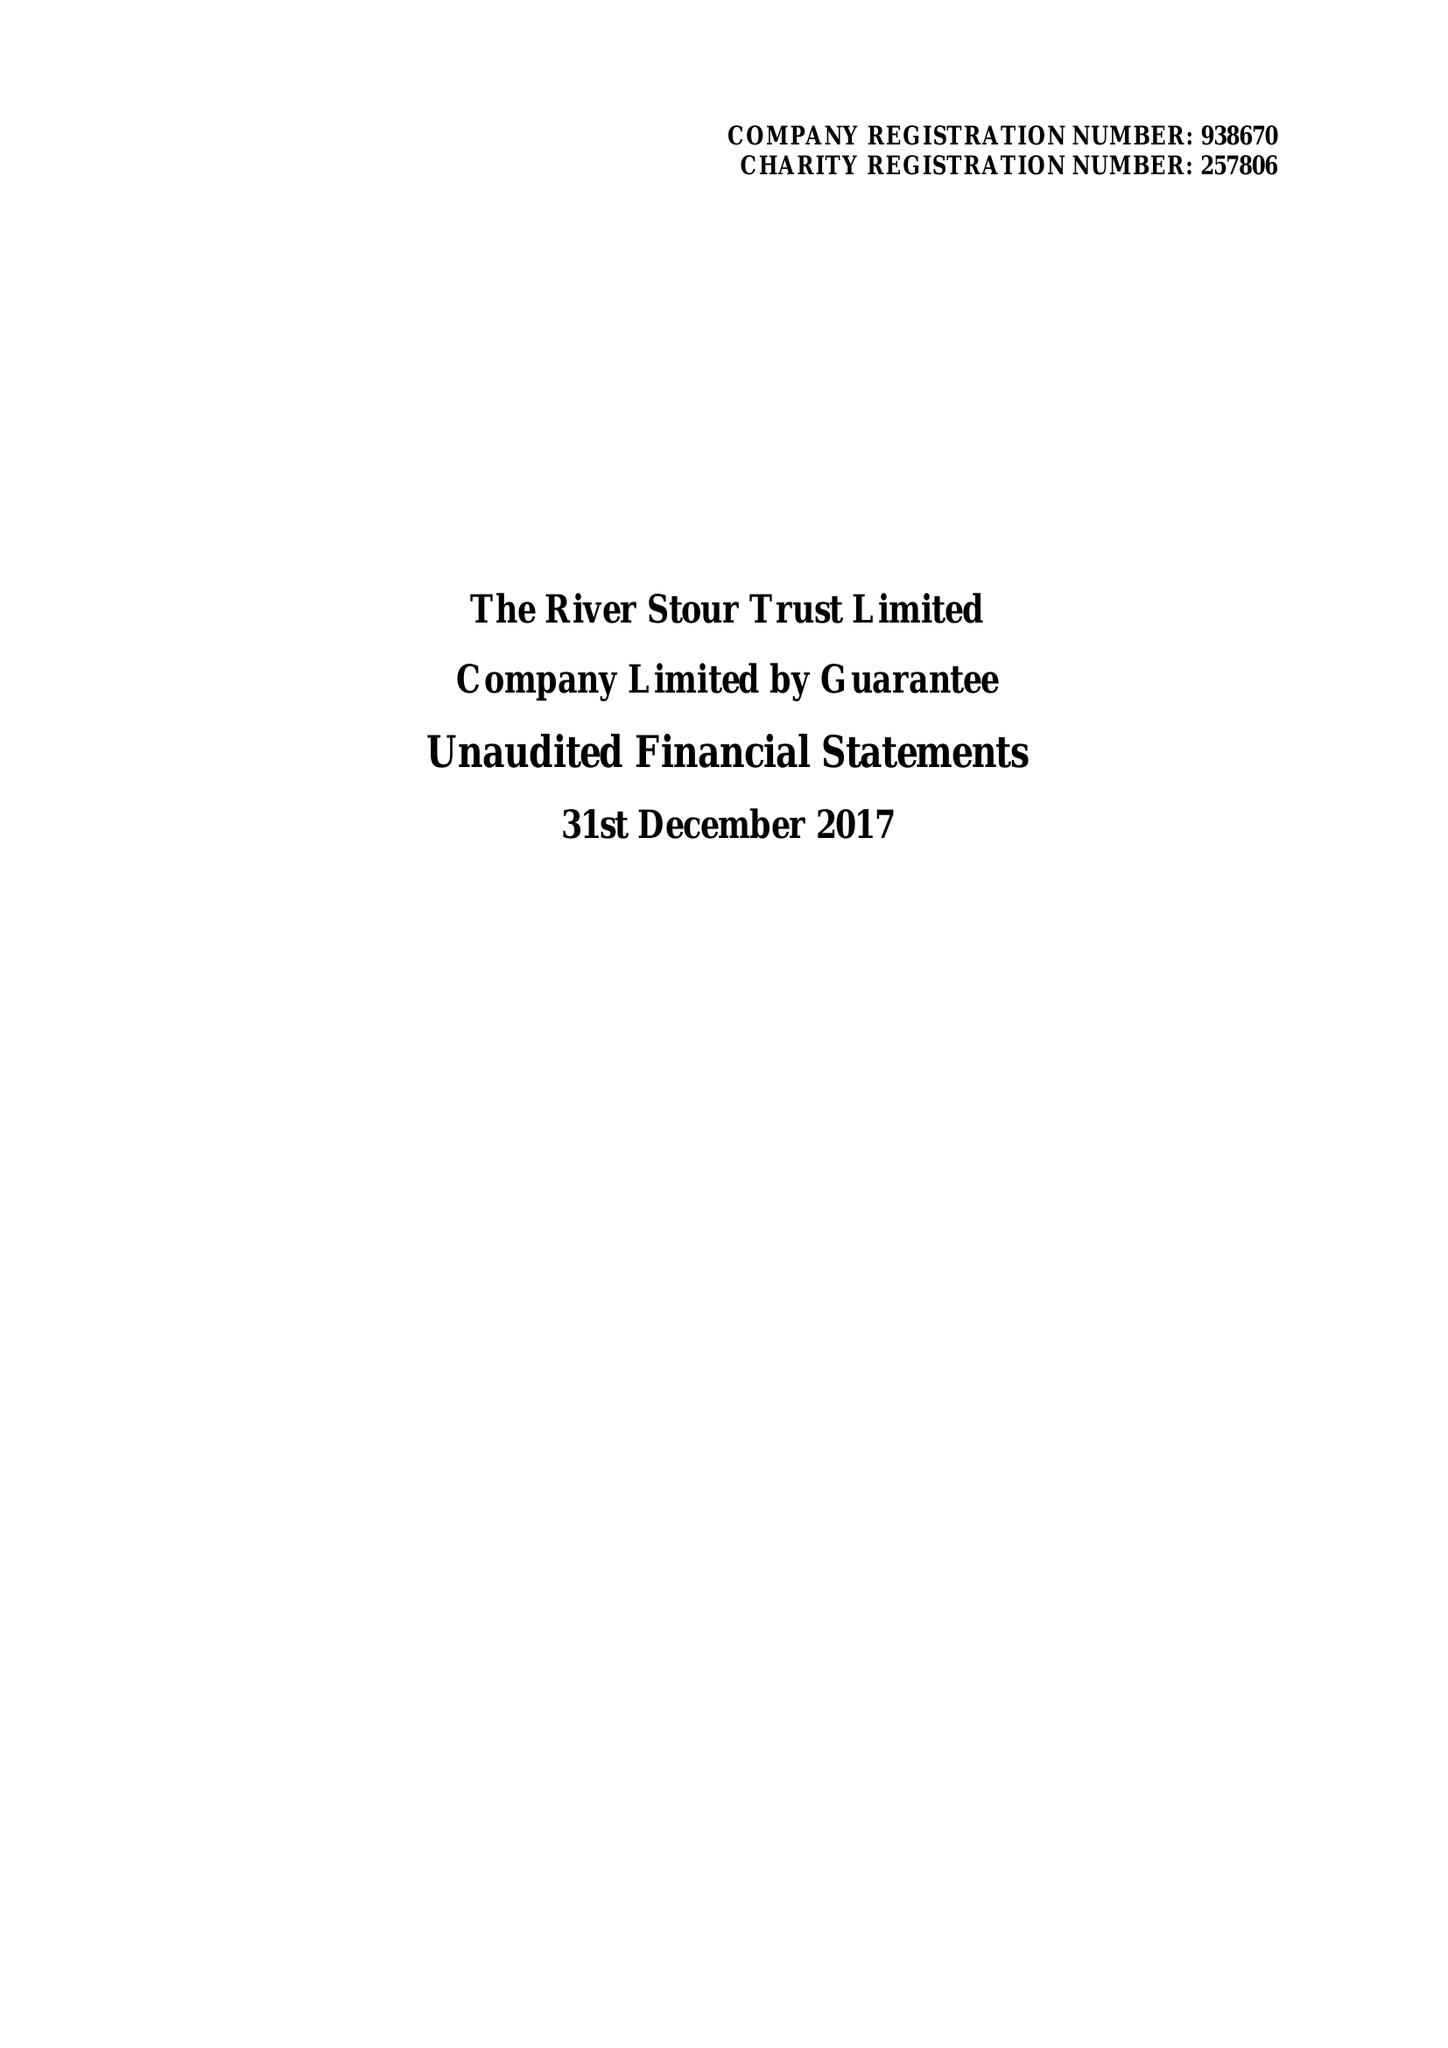What is the value for the income_annually_in_british_pounds?
Answer the question using a single word or phrase. 206143.00 